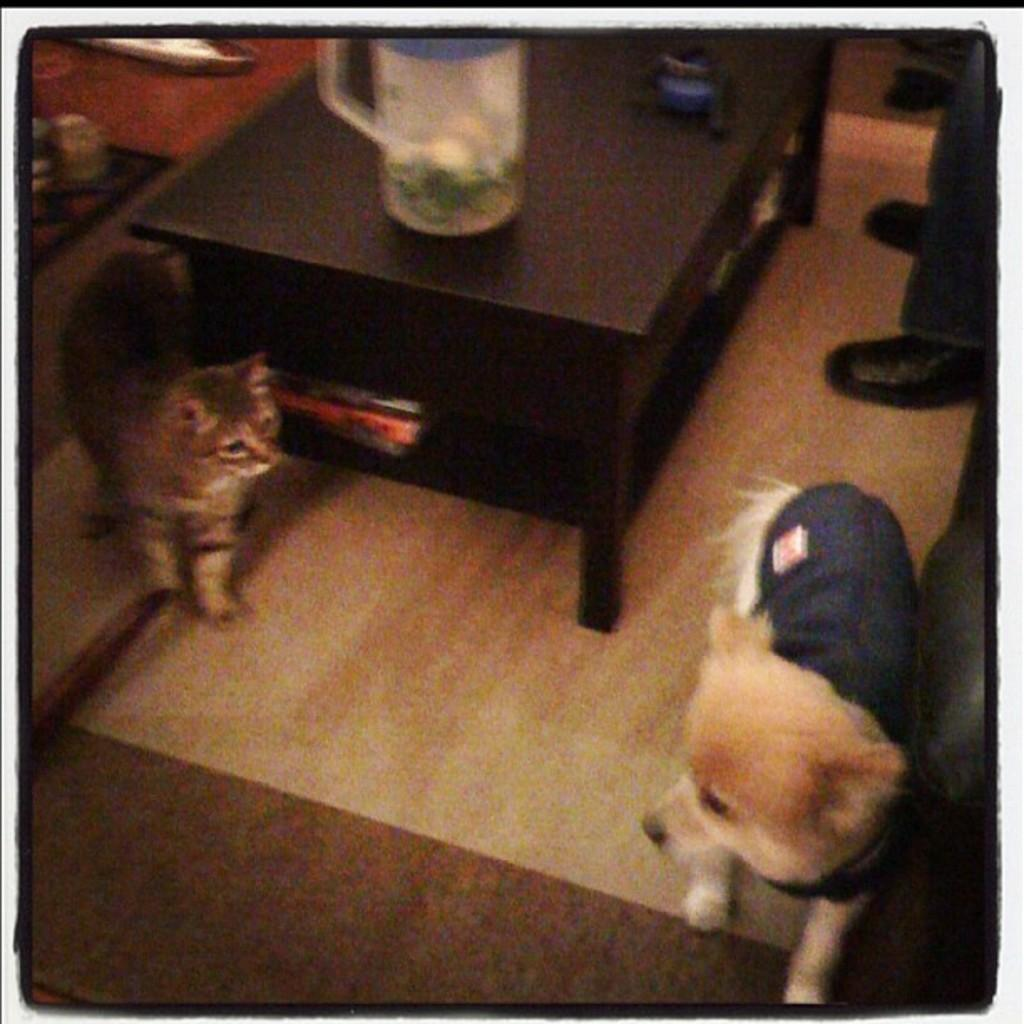Who or what is on the right side of the image? There is a person on the right side of the image. What other living creatures are present in the image? There is a cat and a dog in the image. What object can be seen on a table in the image? There is a jug on a table in the image. What type of soup is being served in the image? There is no soup present in the image. Can you describe the roof of the building in the image? There is no building or roof visible in the image. 